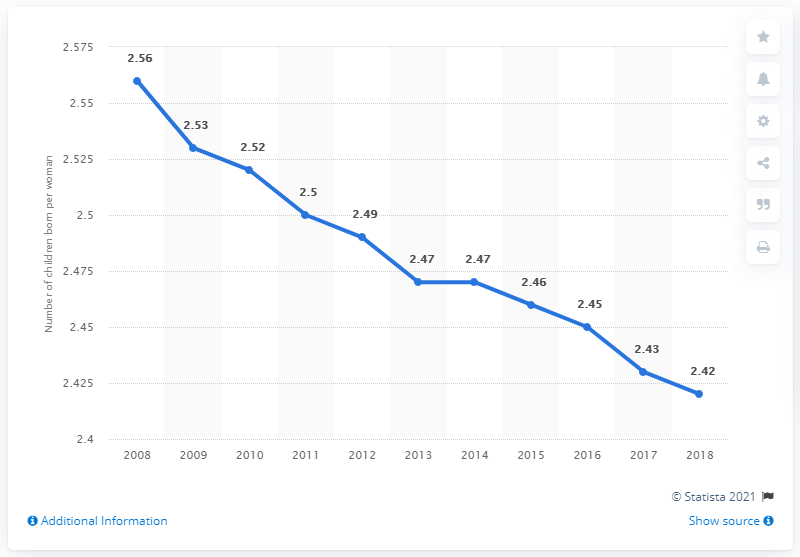Outline some significant characteristics in this image. According to data from 2018, the global fertility rate was 2.42. 